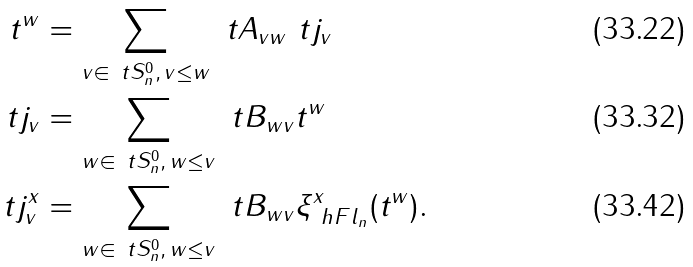<formula> <loc_0><loc_0><loc_500><loc_500>t ^ { w } & = \sum _ { v \in \ t S _ { n } ^ { 0 } , \, v \leq w } \ t A _ { v w } \ t j _ { v } \\ \ t j _ { v } & = \sum _ { w \in \ t S _ { n } ^ { 0 } , \, w \leq v } \ t B _ { w v } t ^ { w } \\ \ t j ^ { x } _ { v } & = \sum _ { w \in \ t S _ { n } ^ { 0 } , \, w \leq v } \ t B _ { w v } \xi ^ { x } _ { \ h F l _ { n } } ( t ^ { w } ) .</formula> 